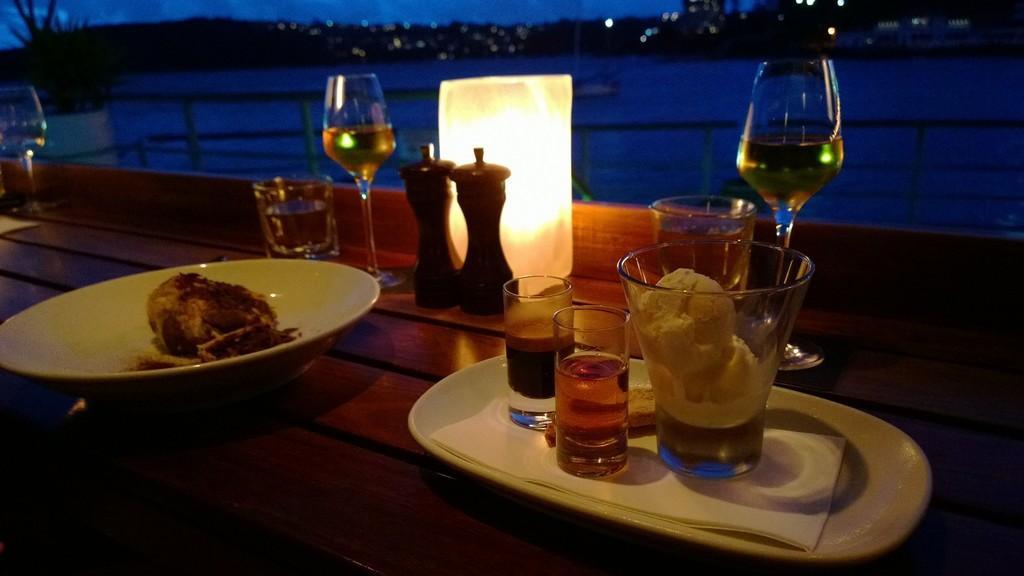In one or two sentences, can you explain what this image depicts? In the picture there is a table and there are glasses, bowls, plates, desserts and candle on the table in the background there is a lake and some trees. 